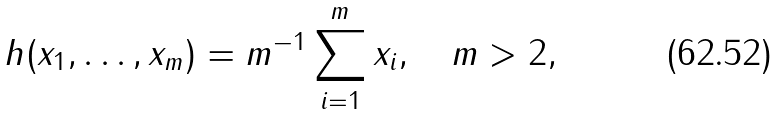Convert formula to latex. <formula><loc_0><loc_0><loc_500><loc_500>h ( x _ { 1 } , \dots , x _ { m } ) = m ^ { - 1 } \sum _ { i = 1 } ^ { m } x _ { i } , \quad m > 2 ,</formula> 